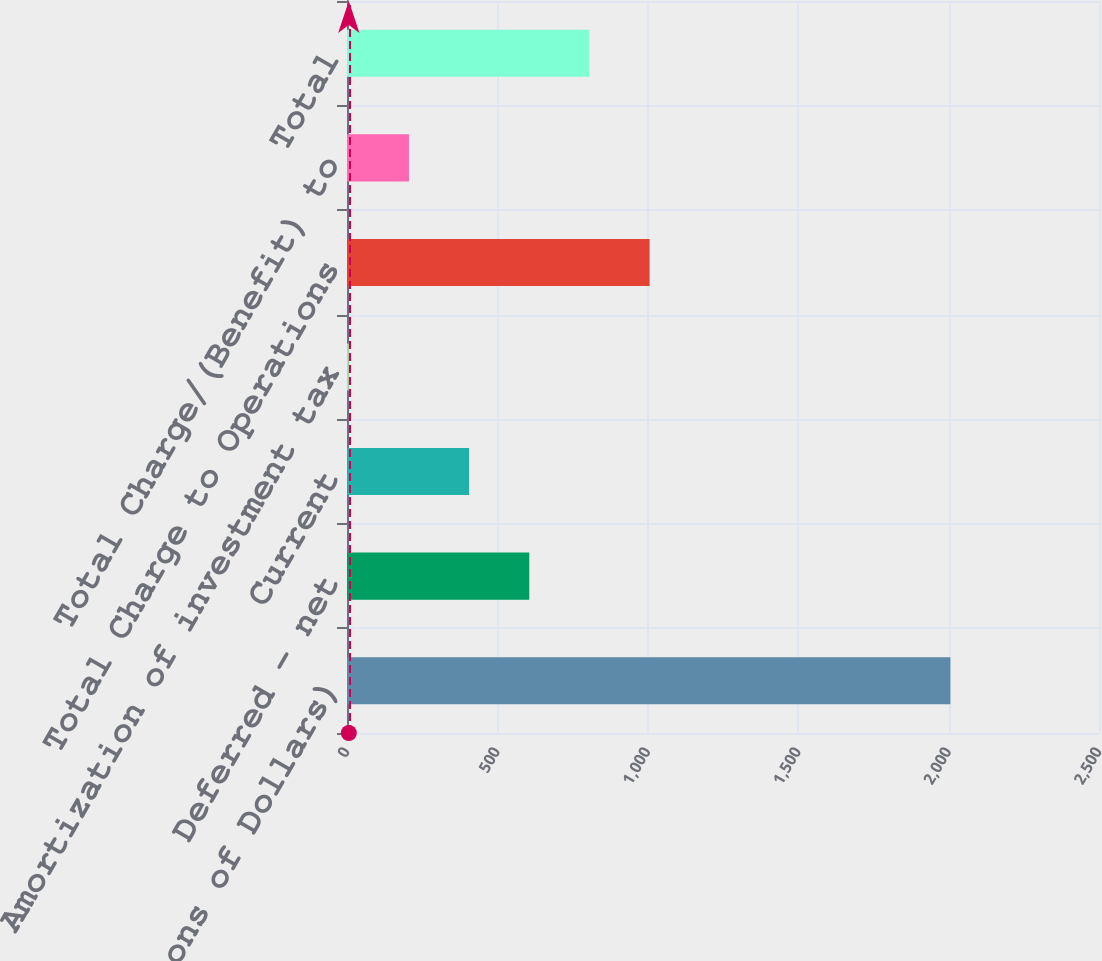<chart> <loc_0><loc_0><loc_500><loc_500><bar_chart><fcel>(Millions of Dollars)<fcel>Deferred - net<fcel>Current<fcel>Amortization of investment tax<fcel>Total Charge to Operations<fcel>Total Charge/(Benefit) to<fcel>Total<nl><fcel>2006<fcel>606<fcel>406<fcel>6<fcel>1006<fcel>206<fcel>806<nl></chart> 